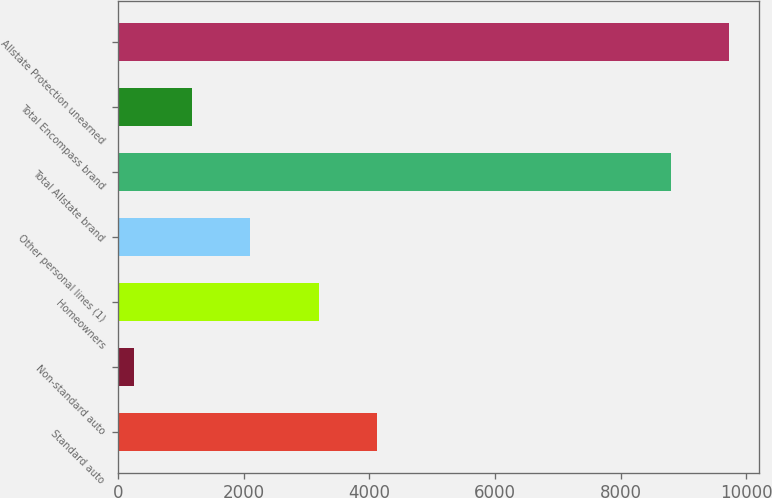<chart> <loc_0><loc_0><loc_500><loc_500><bar_chart><fcel>Standard auto<fcel>Non-standard auto<fcel>Homeowners<fcel>Other personal lines (1)<fcel>Total Allstate brand<fcel>Total Encompass brand<fcel>Allstate Protection unearned<nl><fcel>4116.6<fcel>250<fcel>3193<fcel>2097.2<fcel>8798<fcel>1173.6<fcel>9721.6<nl></chart> 